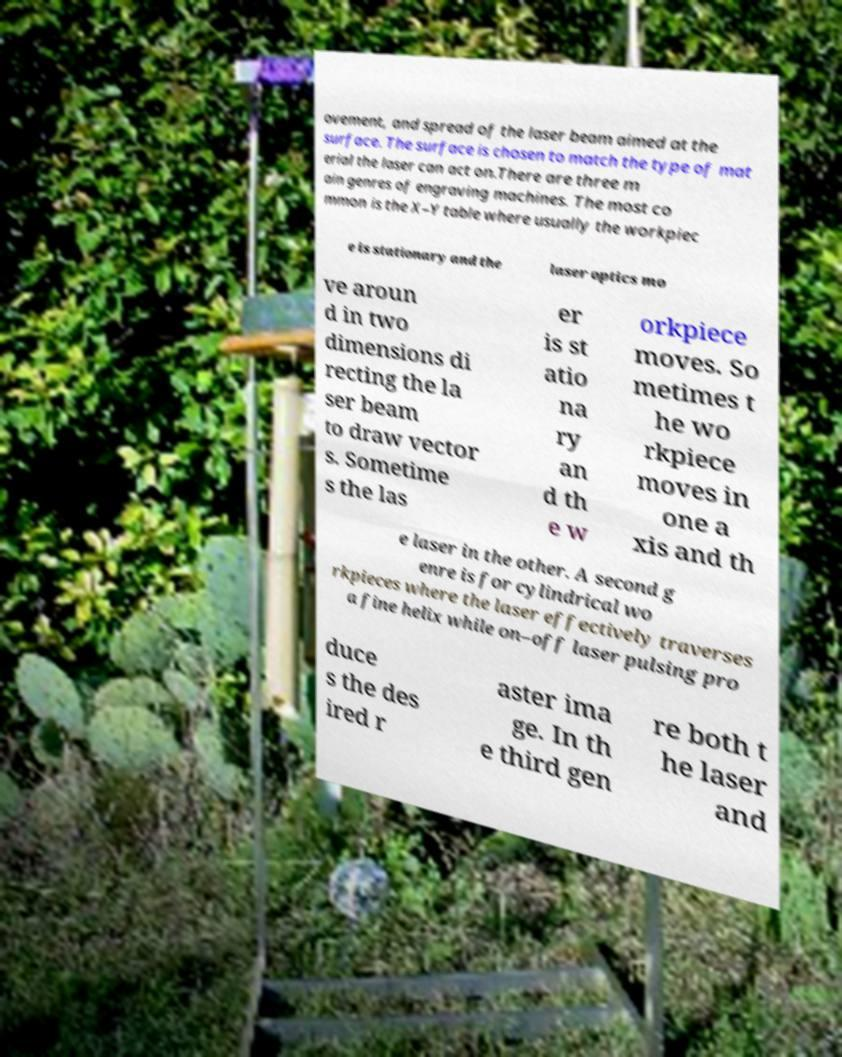I need the written content from this picture converted into text. Can you do that? ovement, and spread of the laser beam aimed at the surface. The surface is chosen to match the type of mat erial the laser can act on.There are three m ain genres of engraving machines. The most co mmon is the X–Y table where usually the workpiec e is stationary and the laser optics mo ve aroun d in two dimensions di recting the la ser beam to draw vector s. Sometime s the las er is st atio na ry an d th e w orkpiece moves. So metimes t he wo rkpiece moves in one a xis and th e laser in the other. A second g enre is for cylindrical wo rkpieces where the laser effectively traverses a fine helix while on–off laser pulsing pro duce s the des ired r aster ima ge. In th e third gen re both t he laser and 